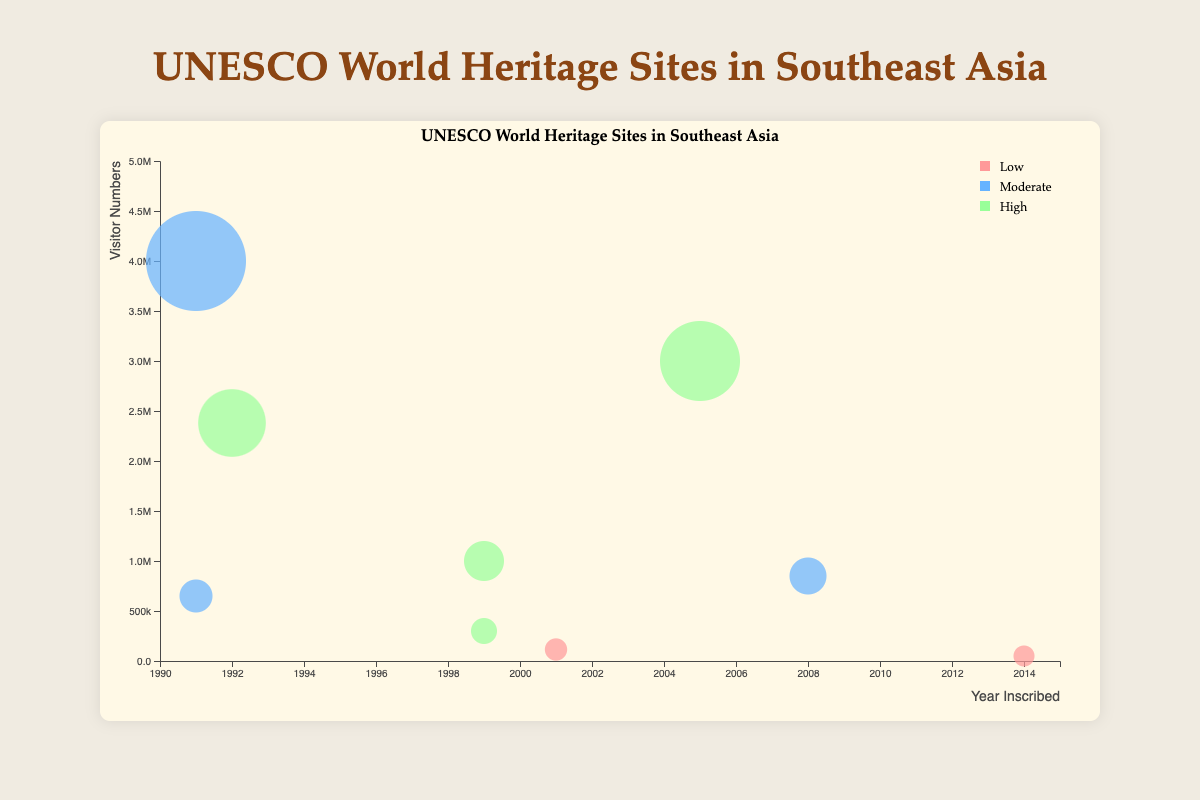What is the title of the chart? The title is located at the top center of the chart, and it summarizes the main subject.
Answer: UNESCO World Heritage Sites in Southeast Asia How many sites in the chart have a preservation effort marked as "High"? By looking at the legend and identifying the color associated with "High" preservation effort, count the number of bubbles with that color.
Answer: 4 Which site has the highest visitor numbers? The bubble size indicates visitor numbers. The largest bubble represents the site with the highest visitor numbers.
Answer: Borobudur Temple Compounds Between "Historic Centre of Macao" and "Angkor", which one was inscribed earlier? Check the x-axis positions of the two bubbles representing these sites. The one closer to the left was inscribed earlier.
Answer: Angkor Which site in Myanmar is represented in the chart? Identify the bubble labeled with the country "Myanmar".
Answer: Pyu Ancient Cities What are the visitor numbers for "Vat Phou and Associated Ancient Settlements" in Laos? Identify the corresponding bubble and read the tooltip information or check its y-axis value.
Answer: 115,000 How do visitor numbers for "My Son Sanctuary" in Vietnam compare to "Historic City of Ayutthaya" in Thailand? Compare the y-axis positions of these two bubbles. The higher the position, the greater the visitor numbers.
Answer: My Son Sanctuary has lower visitor numbers Which year saw the inscription of the Historic Town of Vigan in the Philippines? Determine the x-axis position of the bubble representing this site and check the year.
Answer: 1999 What is the range of years during which the sites in the chart were inscribed? Identify the earliest and latest years from the x-axis values of all bubbles.
Answer: 1991 to 2014 Which site has both "Moderate" preservation efforts and visitor numbers under 100,000? Look for bubbles colored for "Moderate" efforts and check their y-axis values for visitor numbers.
Answer: None 